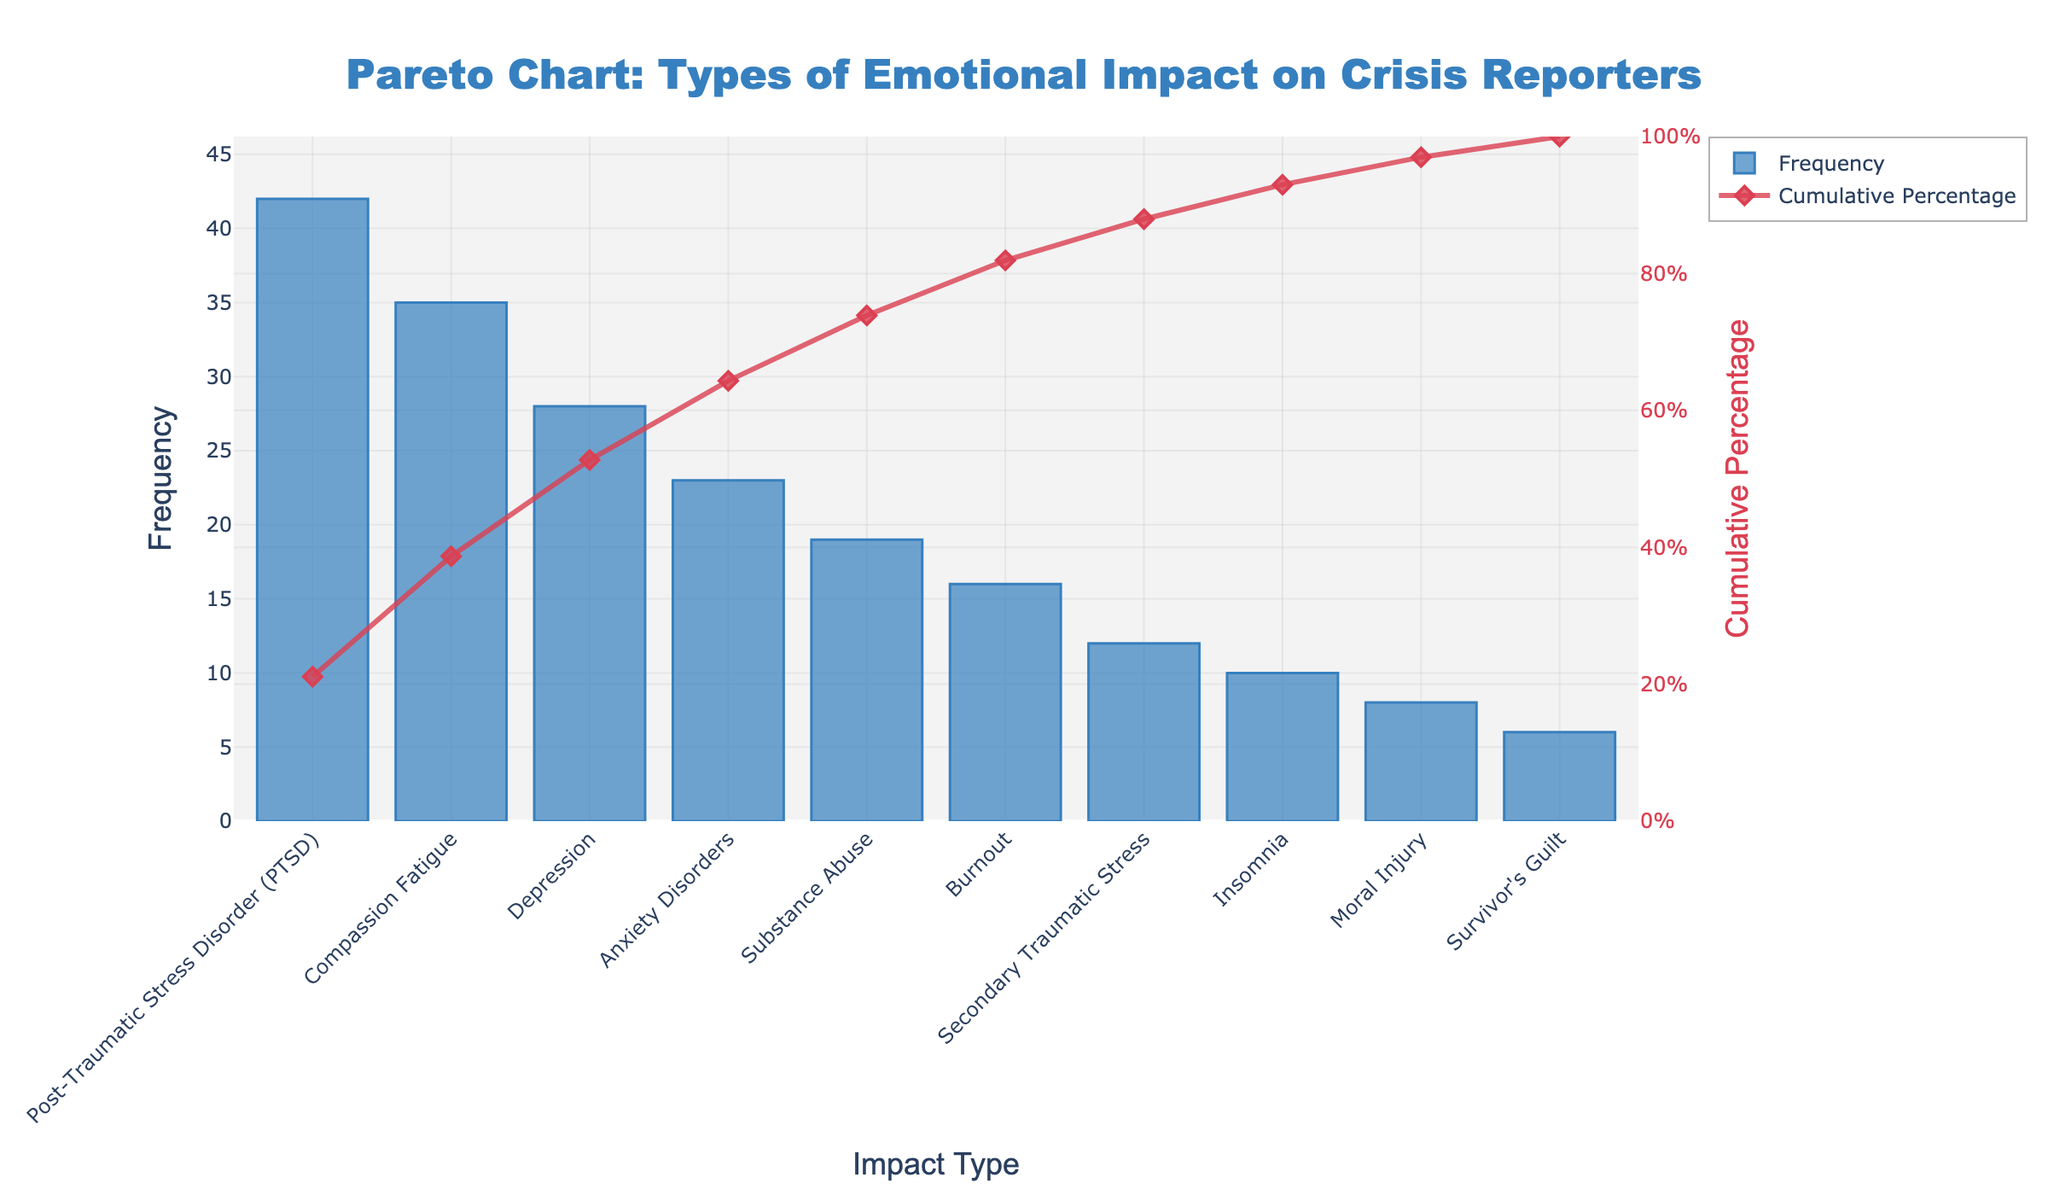What is the title of the chart? The title is positioned at the top center of the figure and provides an overview of the data being presented. It helps the viewer understand what the chart is about.
Answer: Pareto Chart: Types of Emotional Impact on Crisis Reporters Which emotional impact has the highest frequency? The highest bar in the bar chart represents the impact type with the highest frequency. It is the first bar from the left.
Answer: Post-Traumatic Stress Disorder (PTSD) What is the cumulative percentage for Compassion Fatigue? Look for the data point on the line graph corresponding to the 'Compassion Fatigue' category on the x-axis. The y-value on the right y-axis shows the cumulative percentage.
Answer: Around 43.9% How many impact types have a frequency of 20 or more? Count the number of bars in the bar chart that reach or exceed the value of 20 on the y-axis.
Answer: 4 Which emotional impact type contributes to the cumulative percentage reaching approximately 70%? Check the line graph for the data point where the cumulative percentage is around 70%. Then, find the corresponding impact type on the x-axis.
Answer: Anxiety Disorders What is the frequency difference between Depression and Insomnia? Find the heights of the bars corresponding to 'Depression' and 'Insomnia'. Subtract the smaller value from the larger value to get the difference.
Answer: 18 How does the frequency of Substance Abuse compare to Burnout? Compare the heights of the bars representing 'Substance Abuse' and 'Burnout'. The one with the taller bar has a higher frequency.
Answer: Substance Abuse has a higher frequency What percentage of the total emotional impacts is represented by PTSD and Compassion Fatigue combined? Add the frequencies of PTSD and Compassion Fatigue and divide by the total sum of frequencies. Multiply by 100 to convert to a percentage.
Answer: 38.5% Which impact type is the least frequent? The shortest bar in the bar chart represents the impact type with the lowest frequency. It is the last bar to the right.
Answer: Survivor's Guilt Is the cumulative percentage curve increasing uniformly? Check the line graph to see if the curve has a smooth and steady upward slope. An increasing but not uniformly smooth line indicates that the contribution to cumulative percentage varies among the impact types.
Answer: No 